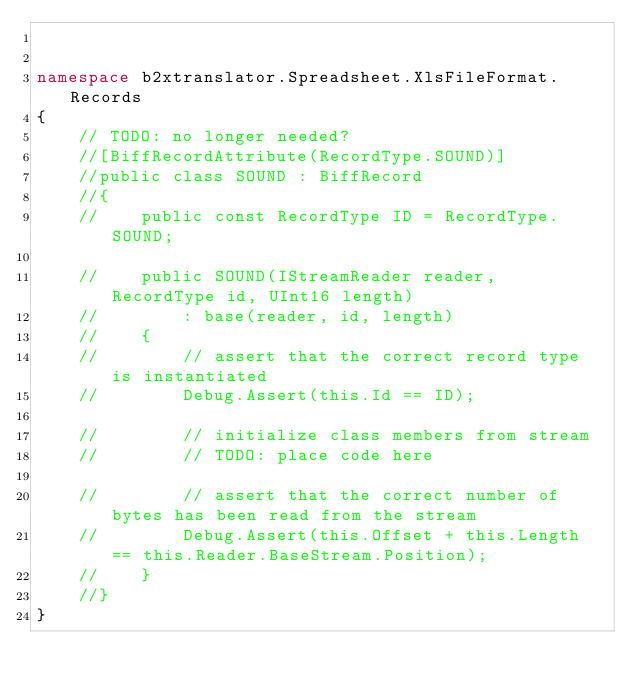<code> <loc_0><loc_0><loc_500><loc_500><_C#_>

namespace b2xtranslator.Spreadsheet.XlsFileFormat.Records
{
    // TODO: no longer needed?
    //[BiffRecordAttribute(RecordType.SOUND)] 
    //public class SOUND : BiffRecord
    //{
    //    public const RecordType ID = RecordType.SOUND;

    //    public SOUND(IStreamReader reader, RecordType id, UInt16 length)
    //        : base(reader, id, length)
    //    {
    //        // assert that the correct record type is instantiated
    //        Debug.Assert(this.Id == ID);

    //        // initialize class members from stream
    //        // TODO: place code here
            
    //        // assert that the correct number of bytes has been read from the stream
    //        Debug.Assert(this.Offset + this.Length == this.Reader.BaseStream.Position); 
    //    }
    //}
}
</code> 